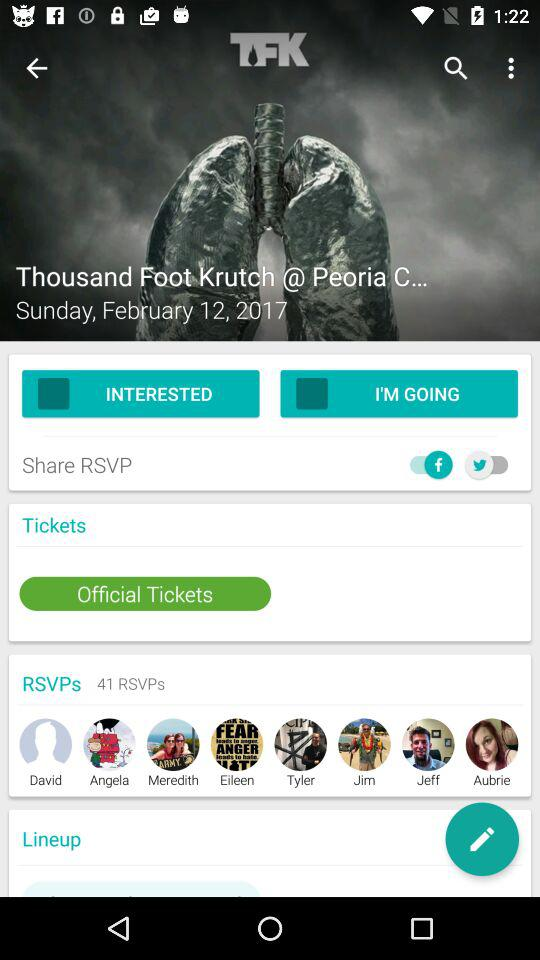How many people have RSVPed to the event?
Answer the question using a single word or phrase. 41 